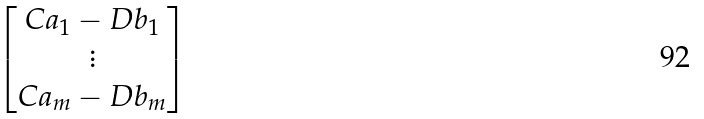Convert formula to latex. <formula><loc_0><loc_0><loc_500><loc_500>\begin{bmatrix} C a _ { 1 } - D b _ { 1 } \\ \vdots \\ C a _ { m } - D b _ { m } \end{bmatrix}</formula> 